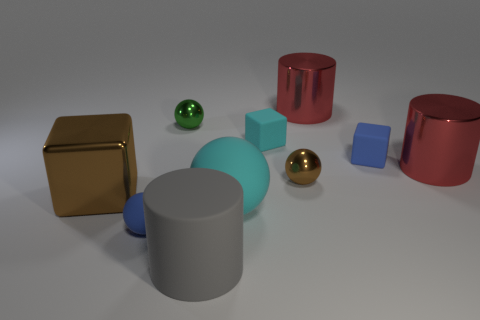Are there any patterns or distinguishing marks on the objects in the picture? The objects in the image are uniformly colored without any patterns or distinguishing marks. Each object has a smooth, unadorned surface that reflects the light in the room. 